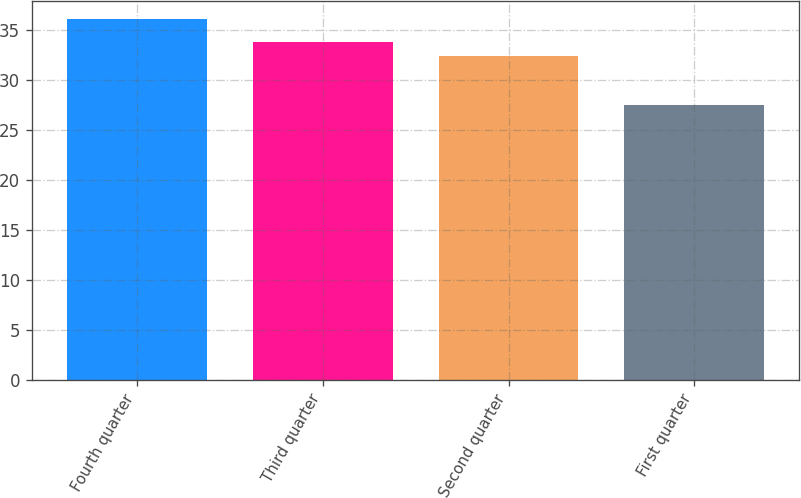<chart> <loc_0><loc_0><loc_500><loc_500><bar_chart><fcel>Fourth quarter<fcel>Third quarter<fcel>Second quarter<fcel>First quarter<nl><fcel>36.08<fcel>33.8<fcel>32.41<fcel>27.53<nl></chart> 